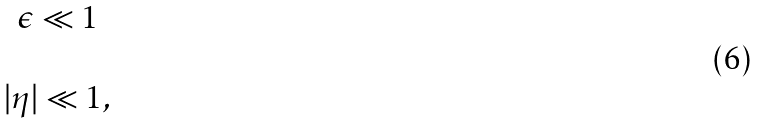Convert formula to latex. <formula><loc_0><loc_0><loc_500><loc_500>\begin{array} { c } \epsilon \ll 1 \\ \\ | \eta | \ll 1 , \end{array}</formula> 